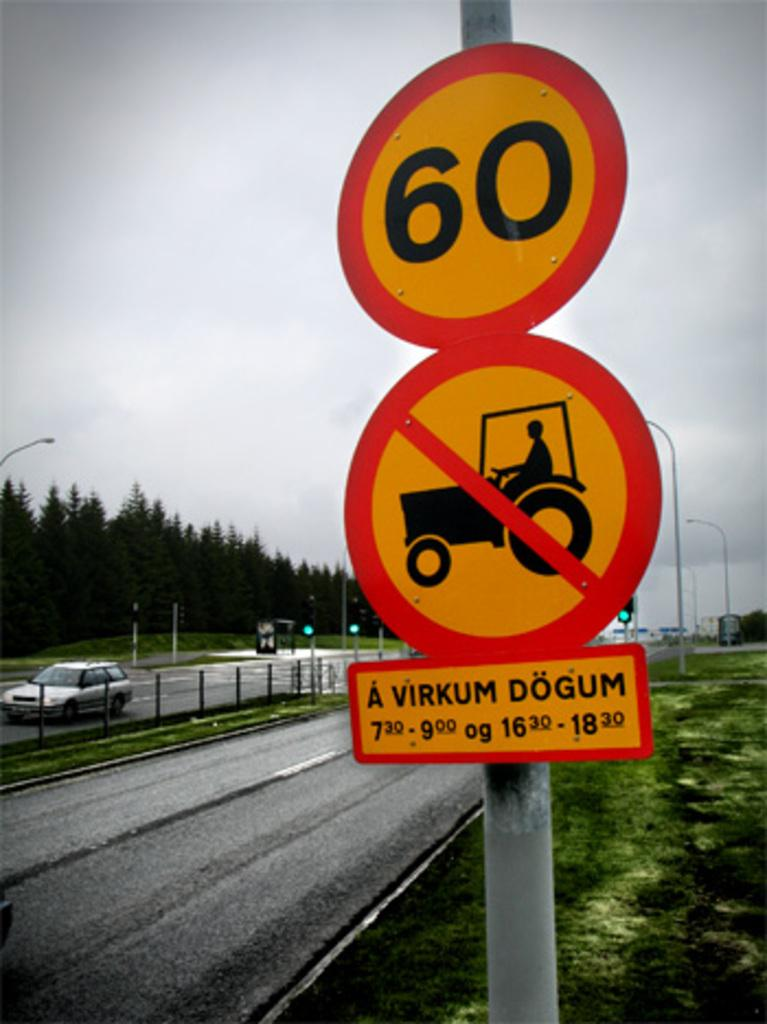<image>
Give a short and clear explanation of the subsequent image. Signs that say 60 and prohibit tractors and say A Virkum Dogum. 